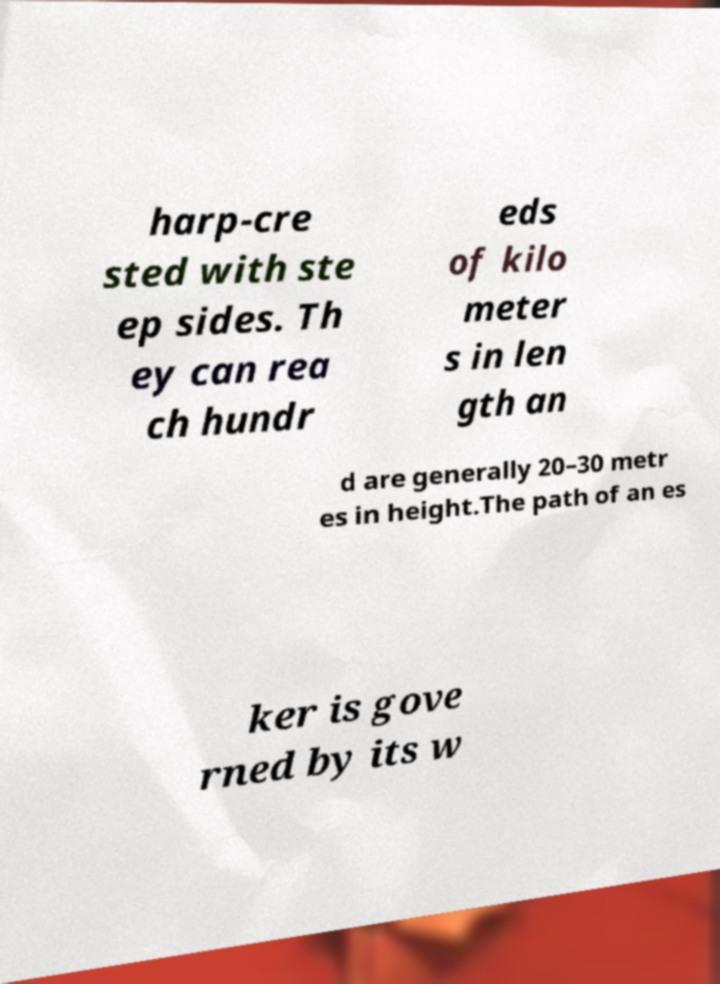I need the written content from this picture converted into text. Can you do that? harp-cre sted with ste ep sides. Th ey can rea ch hundr eds of kilo meter s in len gth an d are generally 20–30 metr es in height.The path of an es ker is gove rned by its w 